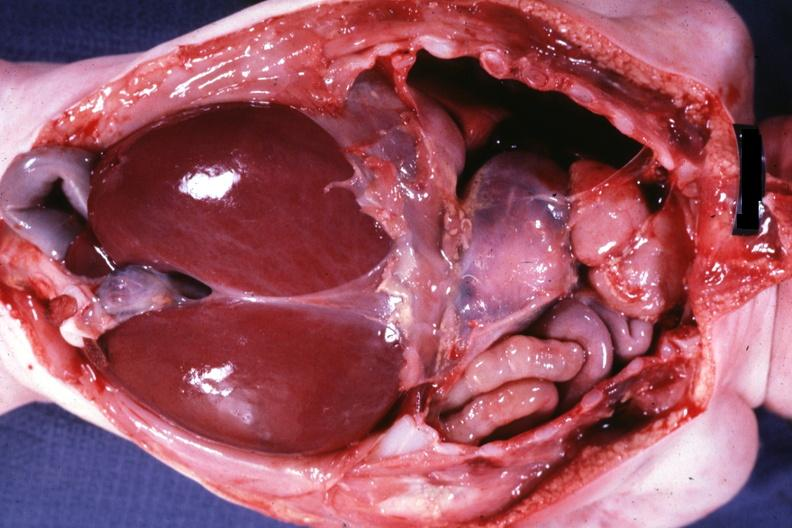what is present?
Answer the question using a single word or phrase. Soft tissue 